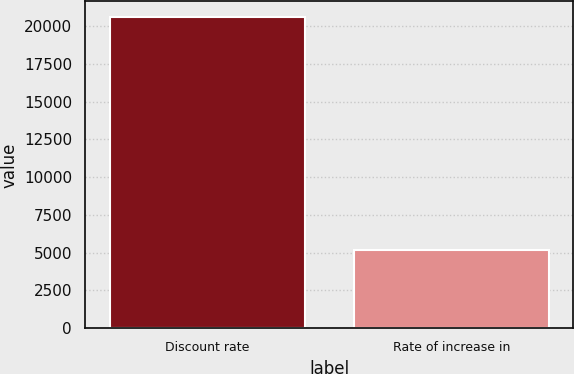Convert chart. <chart><loc_0><loc_0><loc_500><loc_500><bar_chart><fcel>Discount rate<fcel>Rate of increase in<nl><fcel>20608<fcel>5200<nl></chart> 